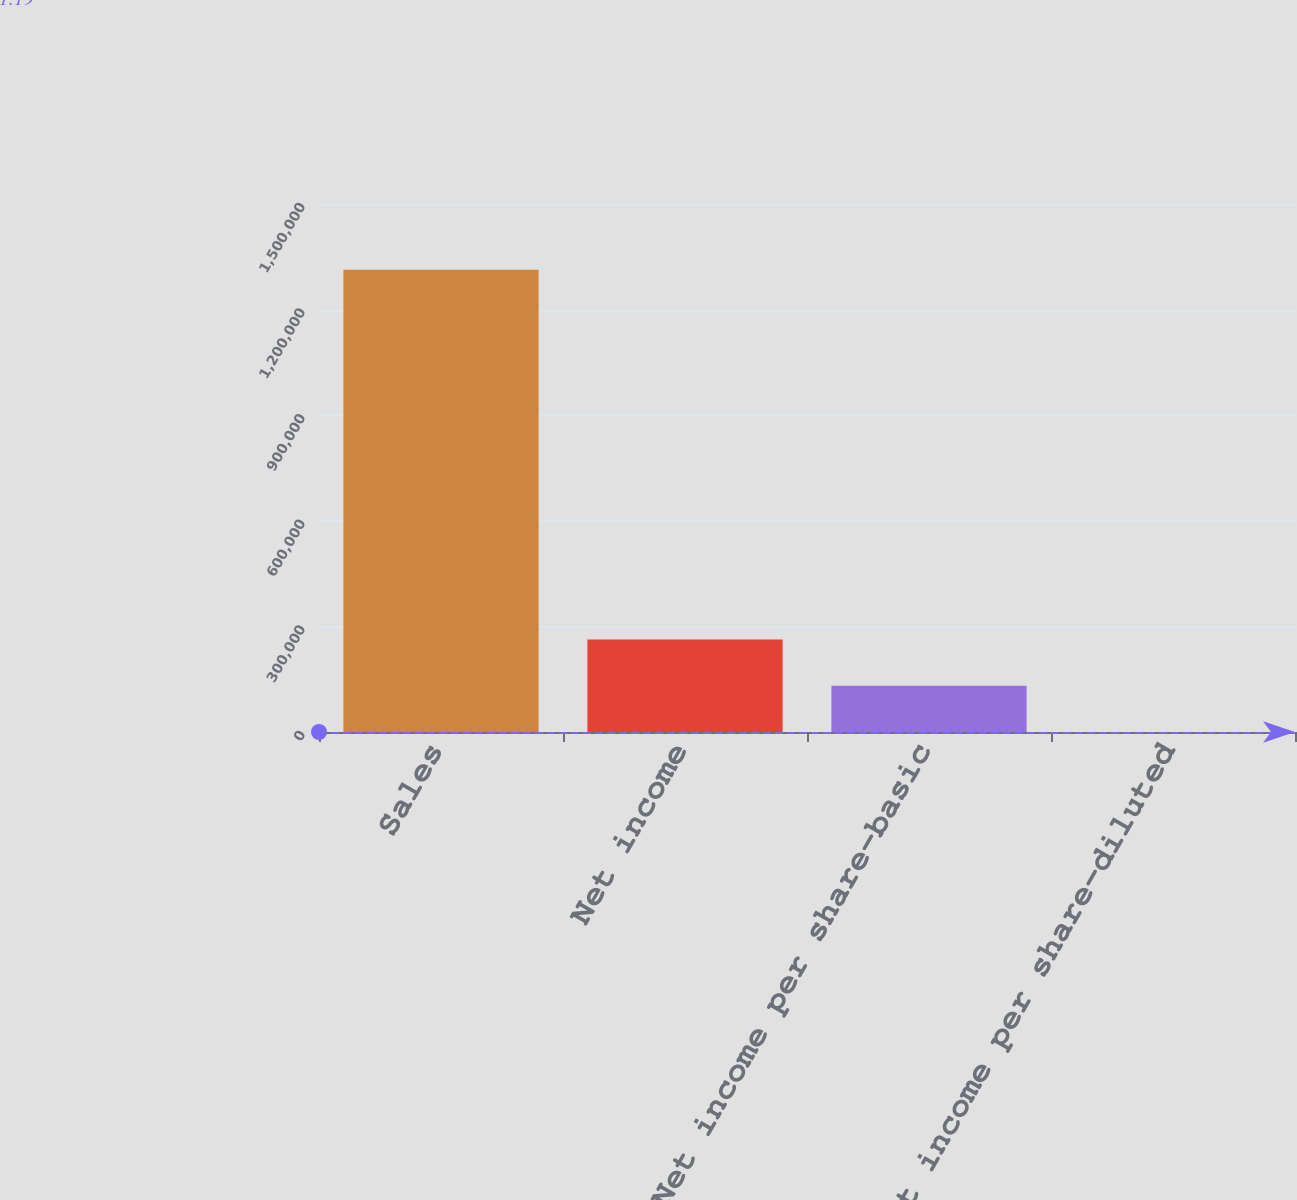<chart> <loc_0><loc_0><loc_500><loc_500><bar_chart><fcel>Sales<fcel>Net income<fcel>Net income per share-basic<fcel>Net income per share-diluted<nl><fcel>1.31309e+06<fcel>262620<fcel>131310<fcel>1.19<nl></chart> 